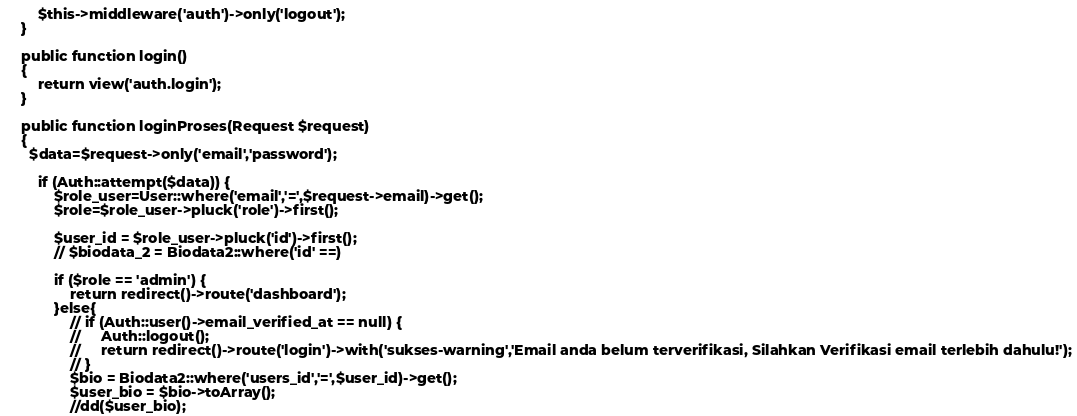Convert code to text. <code><loc_0><loc_0><loc_500><loc_500><_PHP_>        $this->middleware('auth')->only('logout');
    }

    public function login()
    {
        return view('auth.login');
    }

    public function loginProses(Request $request)
    {
      $data=$request->only('email','password');

        if (Auth::attempt($data)) {
            $role_user=User::where('email','=',$request->email)->get();
            $role=$role_user->pluck('role')->first();

            $user_id = $role_user->pluck('id')->first();
            // $biodata_2 = Biodata2::where('id' ==)

            if ($role == 'admin') {
                return redirect()->route('dashboard');            
            }else{
                // if (Auth::user()->email_verified_at == null) {
                //     Auth::logout();
                //     return redirect()->route('login')->with('sukses-warning','Email anda belum terverifikasi, Silahkan Verifikasi email terlebih dahulu!');
                // }
                $bio = Biodata2::where('users_id','=',$user_id)->get();
                $user_bio = $bio->toArray();
                //dd($user_bio);</code> 